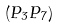<formula> <loc_0><loc_0><loc_500><loc_500>( P _ { 3 } P _ { 7 } )</formula> 